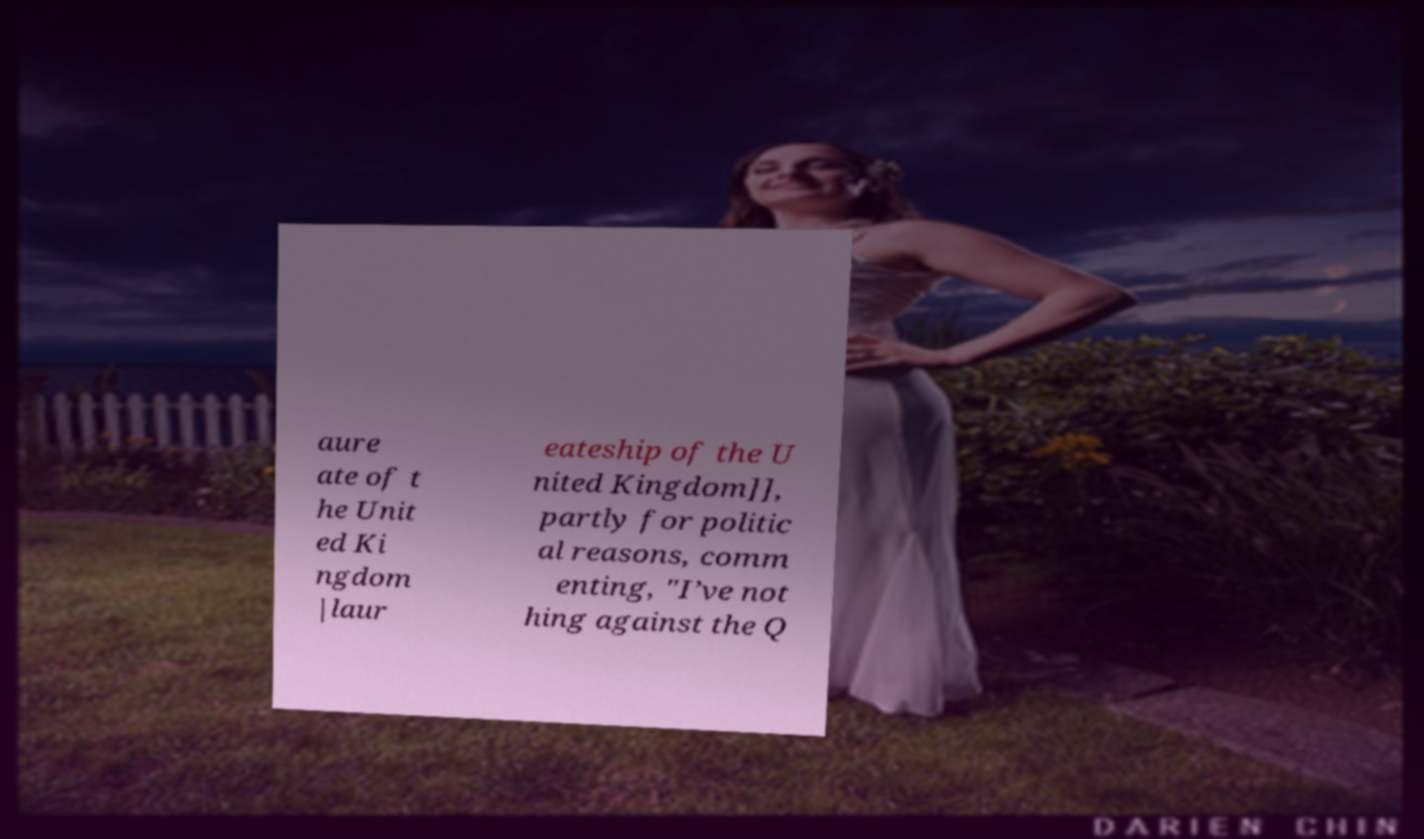For documentation purposes, I need the text within this image transcribed. Could you provide that? aure ate of t he Unit ed Ki ngdom |laur eateship of the U nited Kingdom]], partly for politic al reasons, comm enting, "I’ve not hing against the Q 